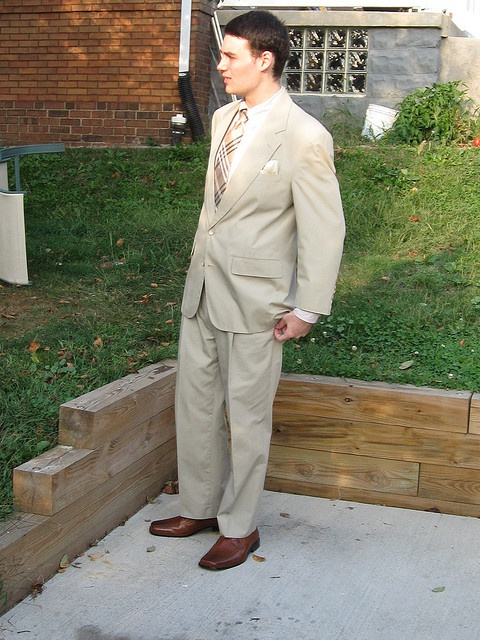Describe the objects in this image and their specific colors. I can see people in black, darkgray, lightgray, tan, and gray tones and tie in black, ivory, tan, and darkgray tones in this image. 